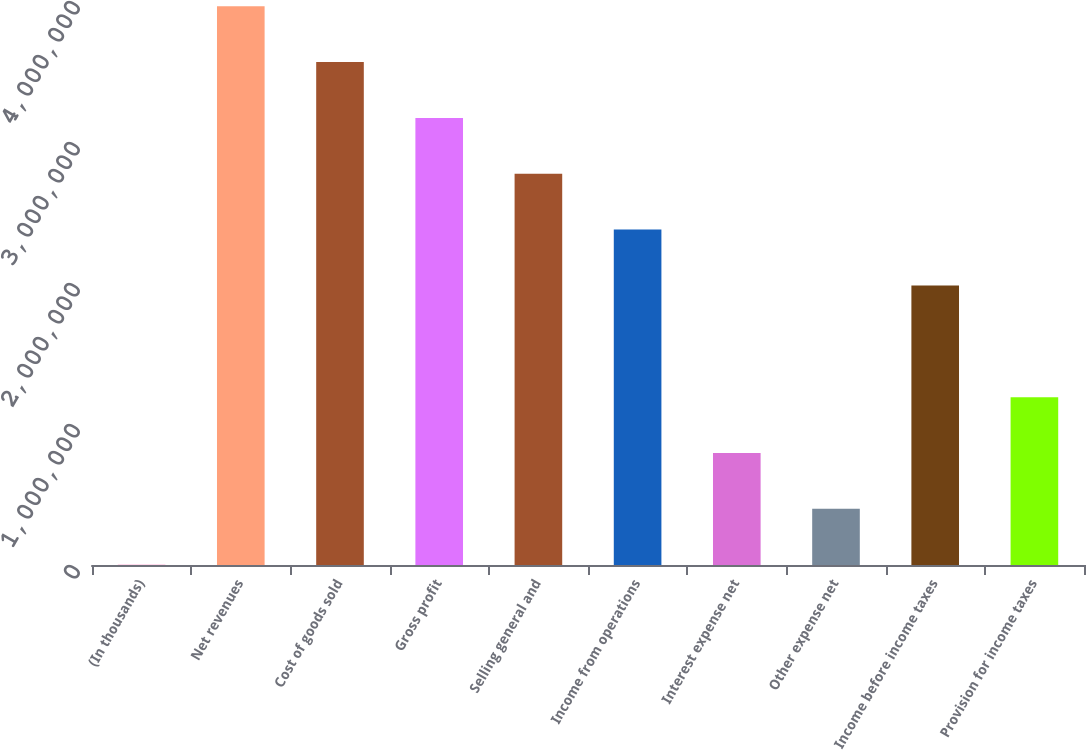Convert chart to OTSL. <chart><loc_0><loc_0><loc_500><loc_500><bar_chart><fcel>(In thousands)<fcel>Net revenues<fcel>Cost of goods sold<fcel>Gross profit<fcel>Selling general and<fcel>Income from operations<fcel>Interest expense net<fcel>Other expense net<fcel>Income before income taxes<fcel>Provision for income taxes<nl><fcel>2015<fcel>3.96331e+06<fcel>3.56718e+06<fcel>3.17105e+06<fcel>2.77492e+06<fcel>2.37879e+06<fcel>794275<fcel>398145<fcel>1.98266e+06<fcel>1.1904e+06<nl></chart> 